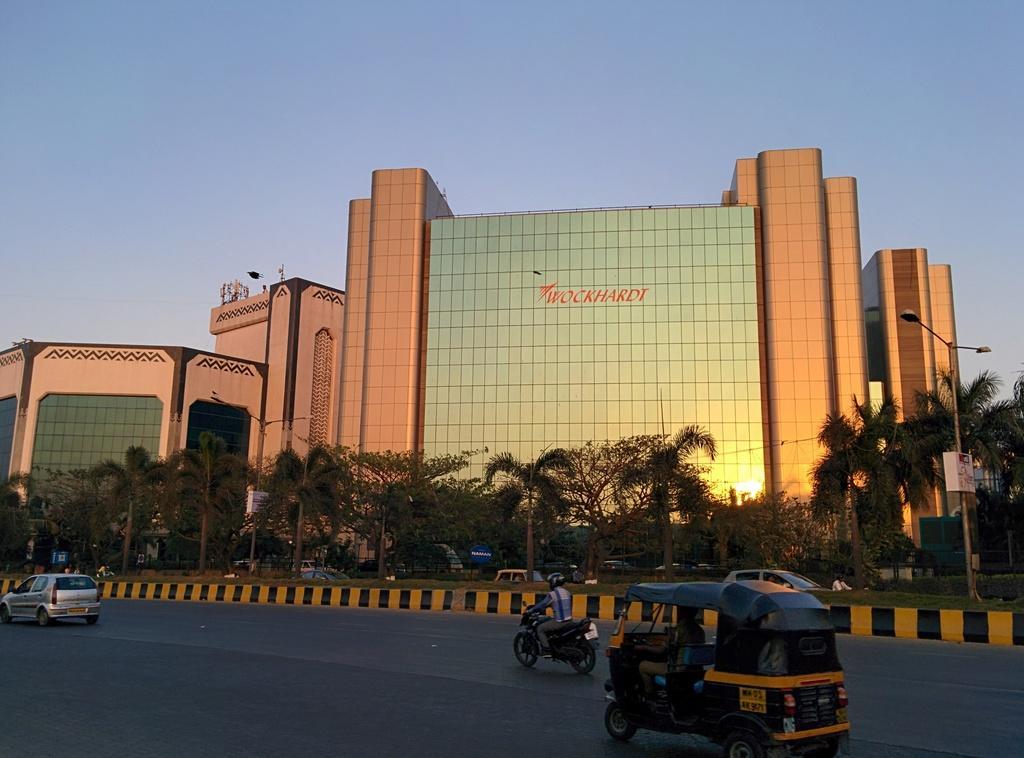Can you describe this image briefly? In this image there is the sky towards the top of the image, there are buildings, there is text on the building, there are trees, there is a pole towards the right of the image, there is a street light, there is a board on the pole, there is a road towards the bottom of the image, there are vehicles on the road, there are persons riding the vehicles. 